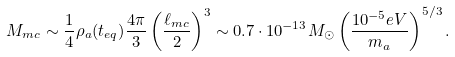Convert formula to latex. <formula><loc_0><loc_0><loc_500><loc_500>M _ { m c } \sim \frac { 1 } { 4 } \rho _ { a } ( t _ { e q } ) { \frac { 4 \pi } { 3 } } \left ( { \frac { \ell _ { m c } } { 2 } } \right ) ^ { 3 } \sim 0 . 7 \cdot 1 0 ^ { - 1 3 } M _ { \odot } \left ( \frac { 1 0 ^ { - 5 } e V } { m _ { a } } \right ) ^ { 5 / 3 } .</formula> 